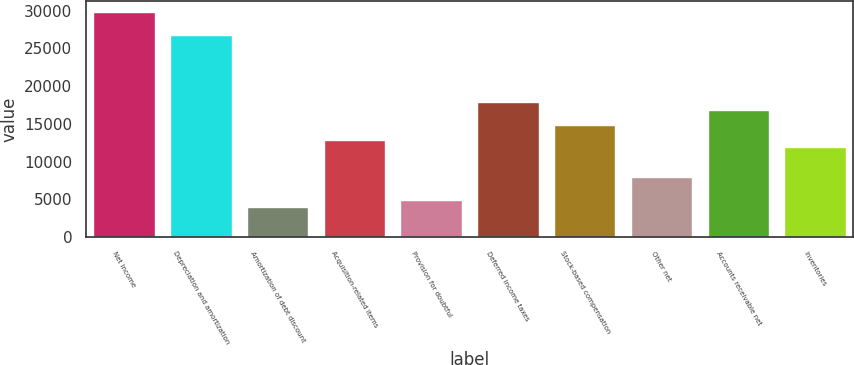<chart> <loc_0><loc_0><loc_500><loc_500><bar_chart><fcel>Net income<fcel>Depreciation and amortization<fcel>Amortization of debt discount<fcel>Acquisition-related items<fcel>Provision for doubtful<fcel>Deferred income taxes<fcel>Stock-based compensation<fcel>Other net<fcel>Accounts receivable net<fcel>Inventories<nl><fcel>29758<fcel>26782.9<fcel>3973.8<fcel>12899.1<fcel>4965.5<fcel>17857.6<fcel>14882.5<fcel>7940.6<fcel>16865.9<fcel>11907.4<nl></chart> 